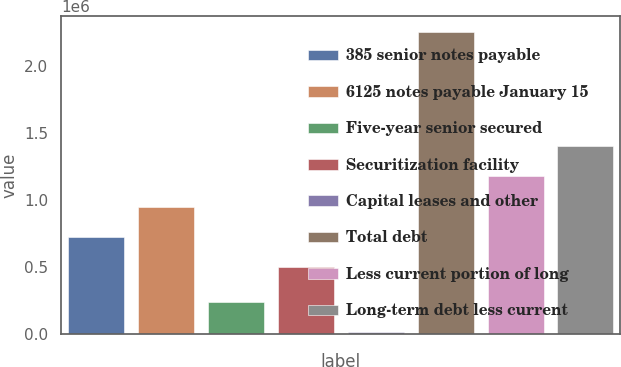Convert chart. <chart><loc_0><loc_0><loc_500><loc_500><bar_chart><fcel>385 senior notes payable<fcel>6125 notes payable January 15<fcel>Five-year senior secured<fcel>Securitization facility<fcel>Capital leases and other<fcel>Total debt<fcel>Less current portion of long<fcel>Long-term debt less current<nl><fcel>724282<fcel>948564<fcel>234902<fcel>500000<fcel>10620<fcel>2.25344e+06<fcel>1.17285e+06<fcel>1.40214e+06<nl></chart> 